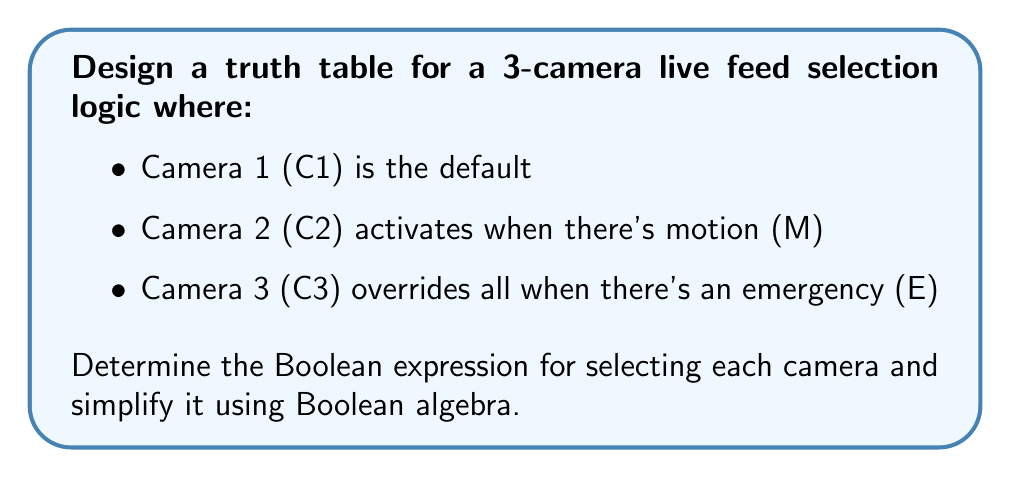Can you answer this question? Step 1: Create the truth table
First, we create a truth table with inputs E, M, C1, C2, and C3 as outputs.

$$
\begin{array}{|c|c|c|c|c|}
\hline
E & M & C1 & C2 & C3 \\
\hline
0 & 0 & 1 & 0 & 0 \\
0 & 1 & 0 & 1 & 0 \\
1 & 0 & 0 & 0 & 1 \\
1 & 1 & 0 & 0 & 1 \\
\hline
\end{array}
$$

Step 2: Write Boolean expressions
From the truth table, we can write the initial Boolean expressions:

$C1 = \overline{E} \cdot \overline{M}$
$C2 = \overline{E} \cdot M$
$C3 = E$

Step 3: Simplify expressions
The expressions for C1 and C2 are already in their simplest forms. C3 is also simple as it depends only on E.

Step 4: Verify the expressions
We can verify that these expressions satisfy the conditions:
- C1 is selected when there's no emergency and no motion
- C2 is selected when there's motion but no emergency
- C3 is selected whenever there's an emergency, regardless of motion

Step 5: Ensure mutual exclusivity
Note that these expressions ensure that only one camera is selected at a time, which is crucial for a live feed selection system.
Answer: $C1 = \overline{E} \cdot \overline{M}$, $C2 = \overline{E} \cdot M$, $C3 = E$ 